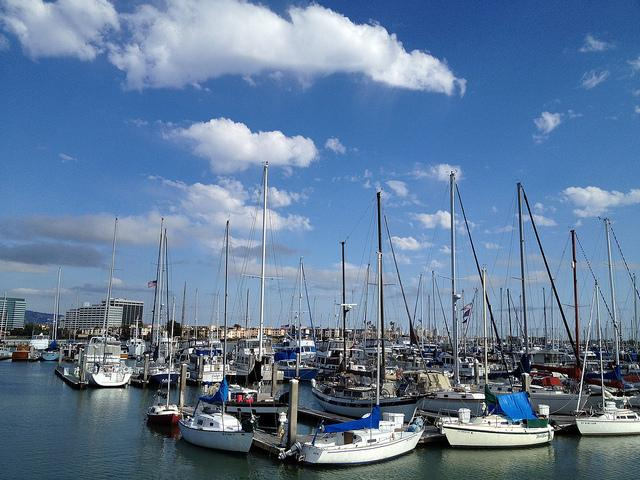Which object on one of the boats would help someone prepare for rain?

Choices:
A) bucket
B) tarp
C) sail
D) motor tarp 